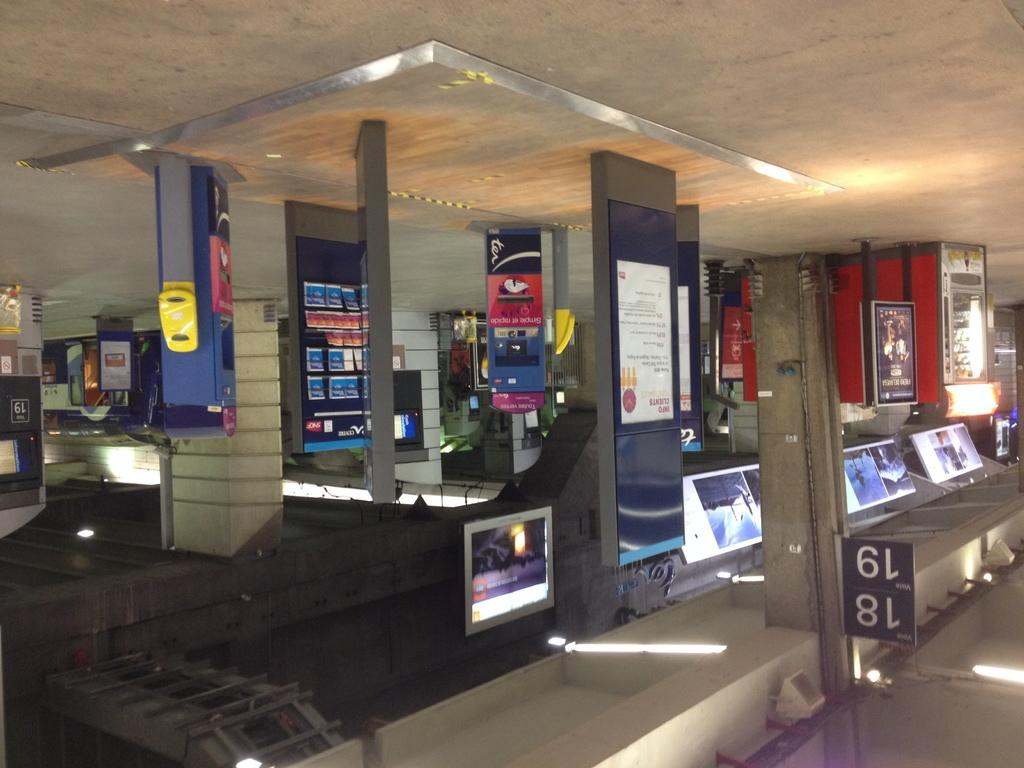Provide a one-sentence caption for the provided image. Aisles 18 and 19 in an electronics store. 